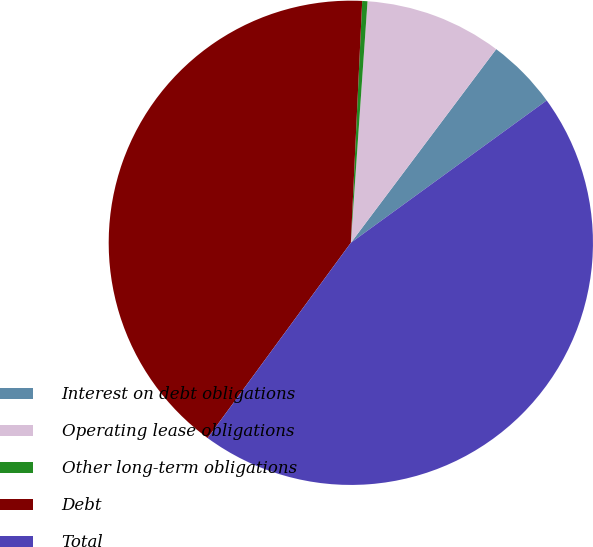<chart> <loc_0><loc_0><loc_500><loc_500><pie_chart><fcel>Interest on debt obligations<fcel>Operating lease obligations<fcel>Other long-term obligations<fcel>Debt<fcel>Total<nl><fcel>4.75%<fcel>9.15%<fcel>0.35%<fcel>40.68%<fcel>45.08%<nl></chart> 